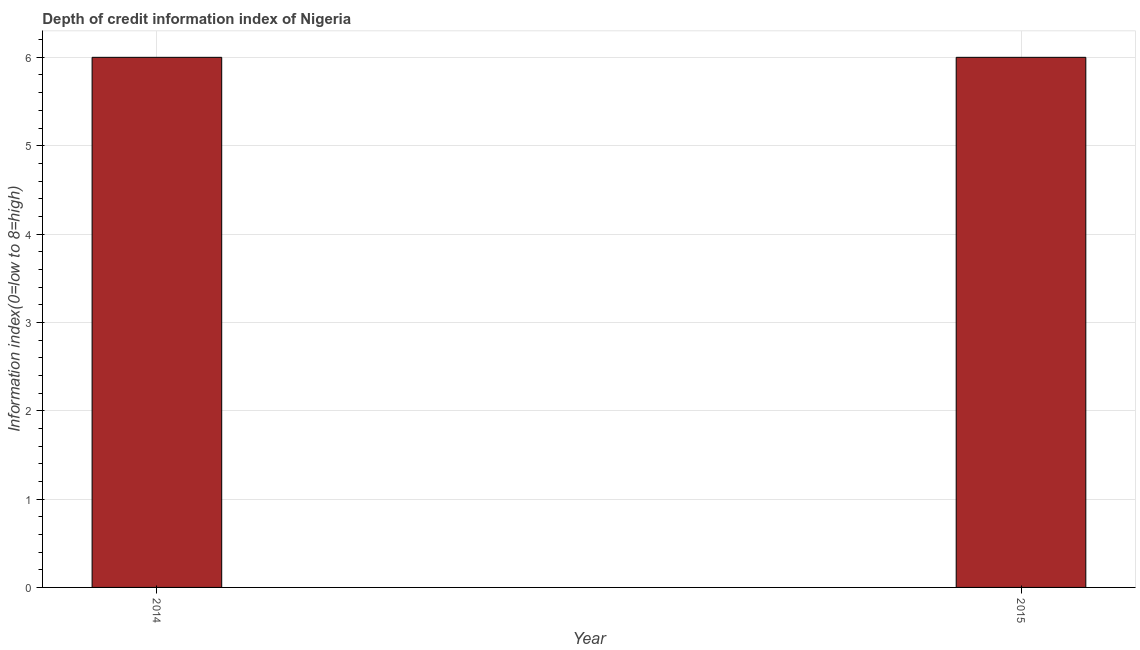Does the graph contain grids?
Your answer should be very brief. Yes. What is the title of the graph?
Provide a short and direct response. Depth of credit information index of Nigeria. What is the label or title of the X-axis?
Provide a short and direct response. Year. What is the label or title of the Y-axis?
Offer a very short reply. Information index(0=low to 8=high). In which year was the depth of credit information index maximum?
Give a very brief answer. 2014. What is the sum of the depth of credit information index?
Provide a succinct answer. 12. What is the average depth of credit information index per year?
Offer a very short reply. 6. What is the median depth of credit information index?
Offer a very short reply. 6. In how many years, is the depth of credit information index greater than 1.6 ?
Offer a terse response. 2. Do a majority of the years between 2015 and 2014 (inclusive) have depth of credit information index greater than 2.2 ?
Your answer should be compact. No. What is the ratio of the depth of credit information index in 2014 to that in 2015?
Give a very brief answer. 1. Is the depth of credit information index in 2014 less than that in 2015?
Offer a terse response. No. In how many years, is the depth of credit information index greater than the average depth of credit information index taken over all years?
Provide a short and direct response. 0. How many bars are there?
Give a very brief answer. 2. Are all the bars in the graph horizontal?
Your answer should be very brief. No. How many years are there in the graph?
Give a very brief answer. 2. What is the Information index(0=low to 8=high) of 2015?
Offer a very short reply. 6. What is the difference between the Information index(0=low to 8=high) in 2014 and 2015?
Make the answer very short. 0. 